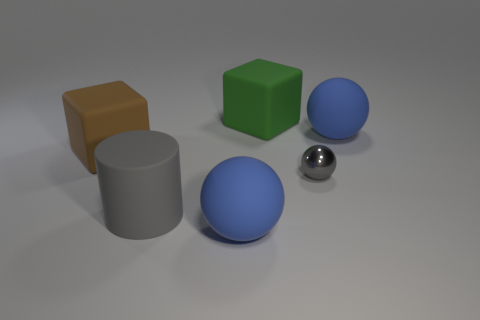Subtract all tiny metal spheres. How many spheres are left? 2 Subtract all gray balls. How many balls are left? 2 Add 2 large brown objects. How many objects exist? 8 Subtract all blocks. How many objects are left? 4 Subtract 2 balls. How many balls are left? 1 Subtract all gray cubes. Subtract all gray cylinders. How many cubes are left? 2 Subtract all purple spheres. How many brown cubes are left? 1 Subtract all large balls. Subtract all matte balls. How many objects are left? 2 Add 1 large gray cylinders. How many large gray cylinders are left? 2 Add 5 big brown matte things. How many big brown matte things exist? 6 